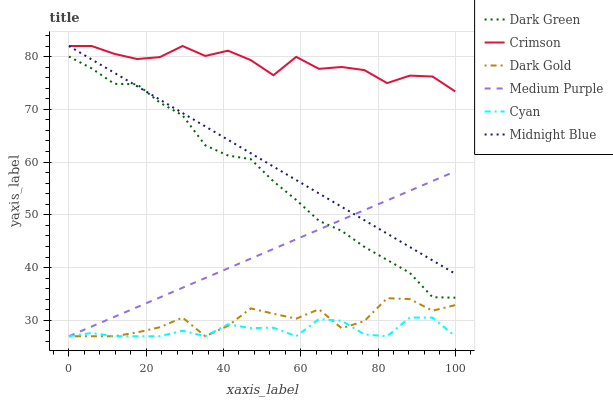Does Dark Gold have the minimum area under the curve?
Answer yes or no. No. Does Dark Gold have the maximum area under the curve?
Answer yes or no. No. Is Dark Gold the smoothest?
Answer yes or no. No. Is Medium Purple the roughest?
Answer yes or no. No. Does Crimson have the lowest value?
Answer yes or no. No. Does Dark Gold have the highest value?
Answer yes or no. No. Is Dark Gold less than Midnight Blue?
Answer yes or no. Yes. Is Crimson greater than Cyan?
Answer yes or no. Yes. Does Dark Gold intersect Midnight Blue?
Answer yes or no. No. 